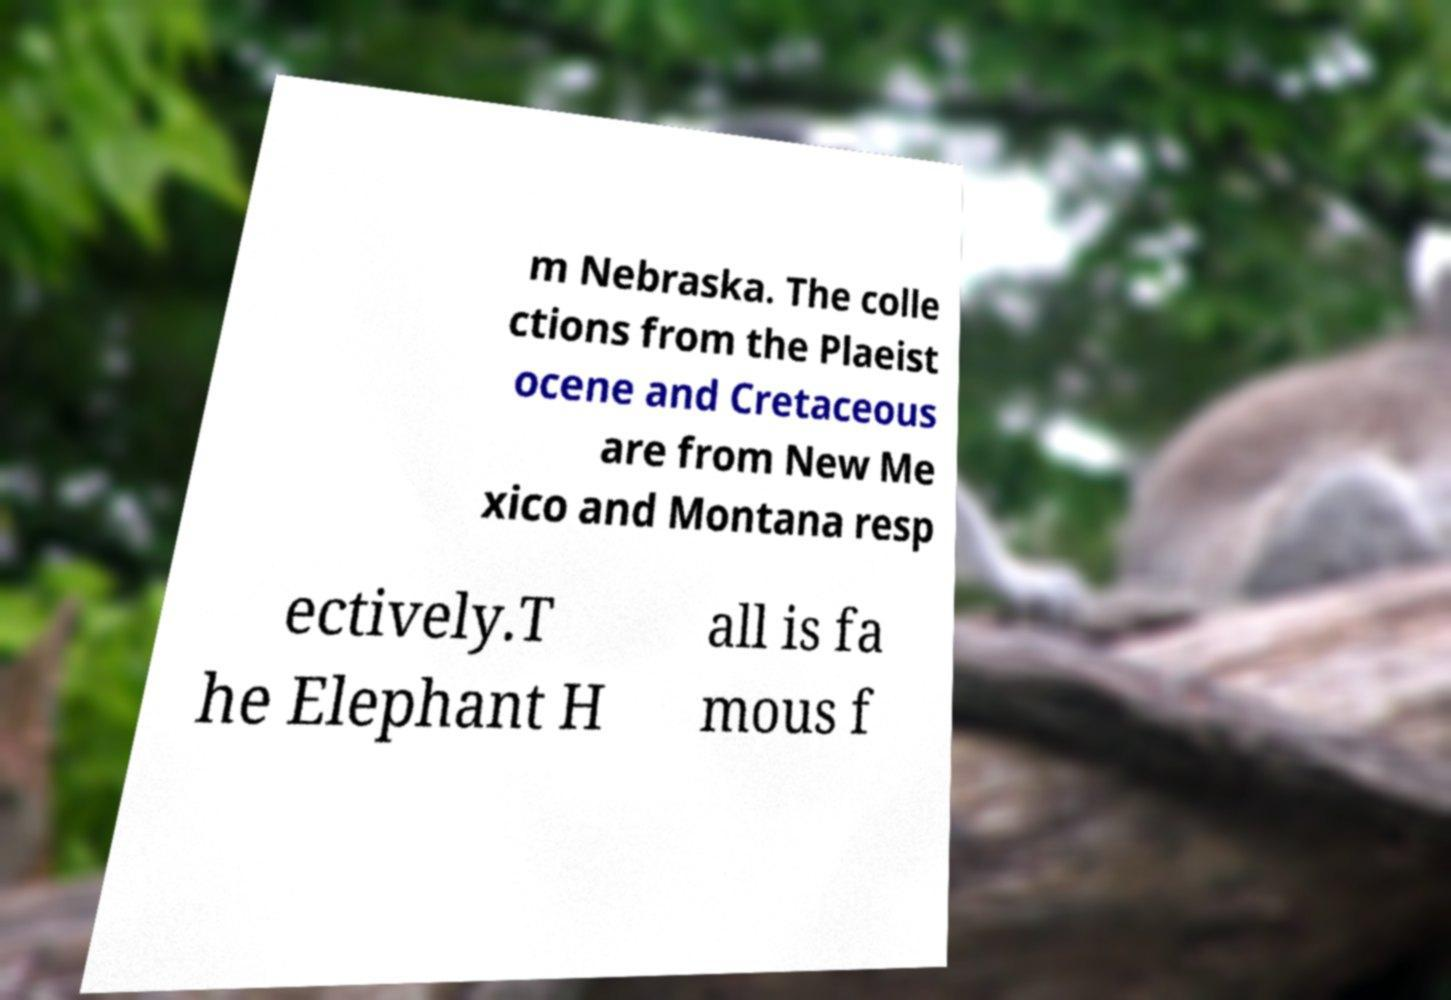Could you extract and type out the text from this image? m Nebraska. The colle ctions from the Plaeist ocene and Cretaceous are from New Me xico and Montana resp ectively.T he Elephant H all is fa mous f 